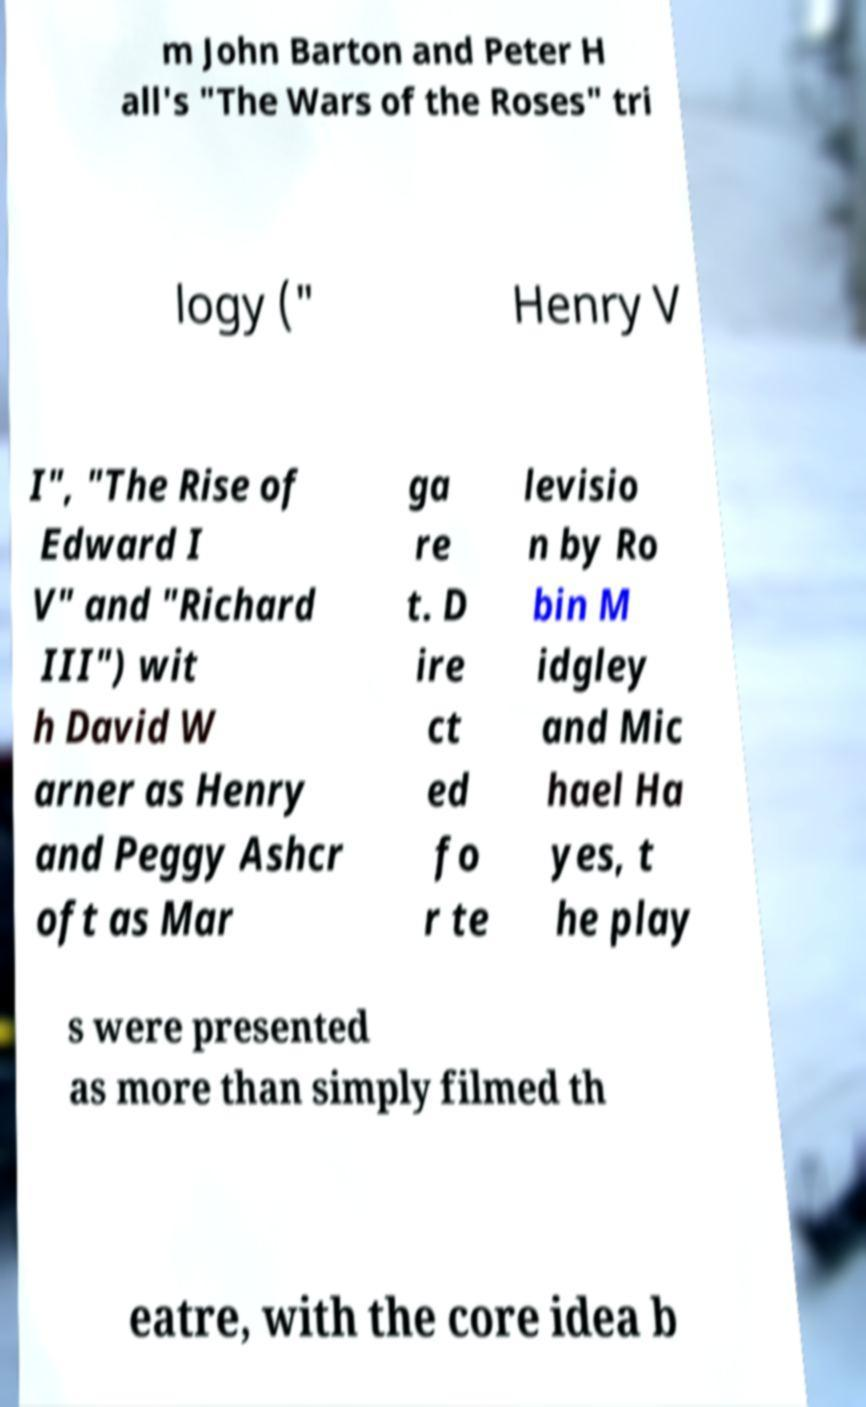There's text embedded in this image that I need extracted. Can you transcribe it verbatim? m John Barton and Peter H all's "The Wars of the Roses" tri logy (" Henry V I", "The Rise of Edward I V" and "Richard III") wit h David W arner as Henry and Peggy Ashcr oft as Mar ga re t. D ire ct ed fo r te levisio n by Ro bin M idgley and Mic hael Ha yes, t he play s were presented as more than simply filmed th eatre, with the core idea b 